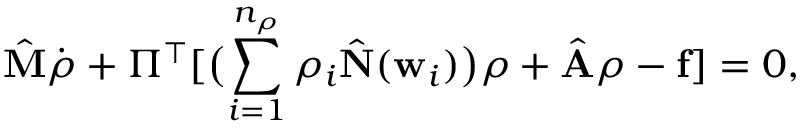Convert formula to latex. <formula><loc_0><loc_0><loc_500><loc_500>{ \hat { M } } \dot { { \rho } } + \Pi ^ { \top } [ \left ( \sum _ { i = 1 } ^ { n _ { \rho } } \rho _ { i } { \hat { N } } ( { w } _ { i } ) \right ) { \rho } + { \hat { A } } { \rho } - { f } ] = 0 ,</formula> 